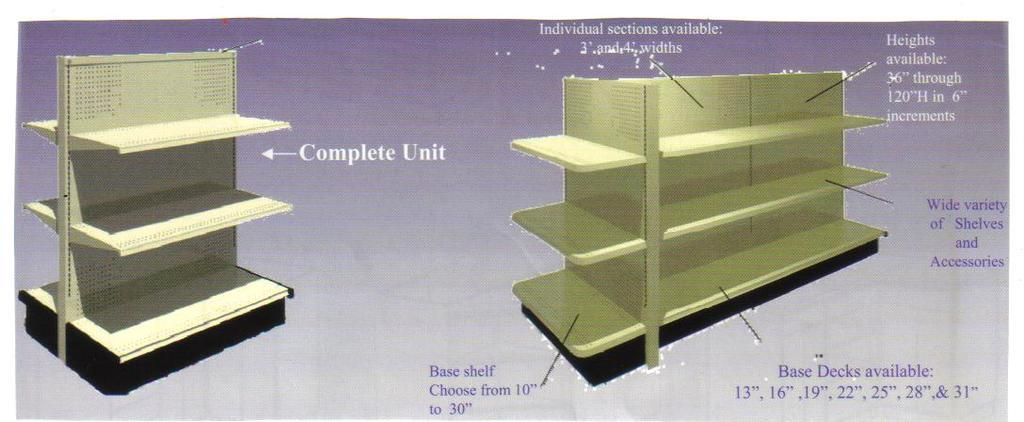<image>
Provide a brief description of the given image. A complete shelving unit and a second with dimensions and options are shown. 